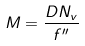<formula> <loc_0><loc_0><loc_500><loc_500>M = \frac { D N _ { v } } { f ^ { \prime \prime } }</formula> 